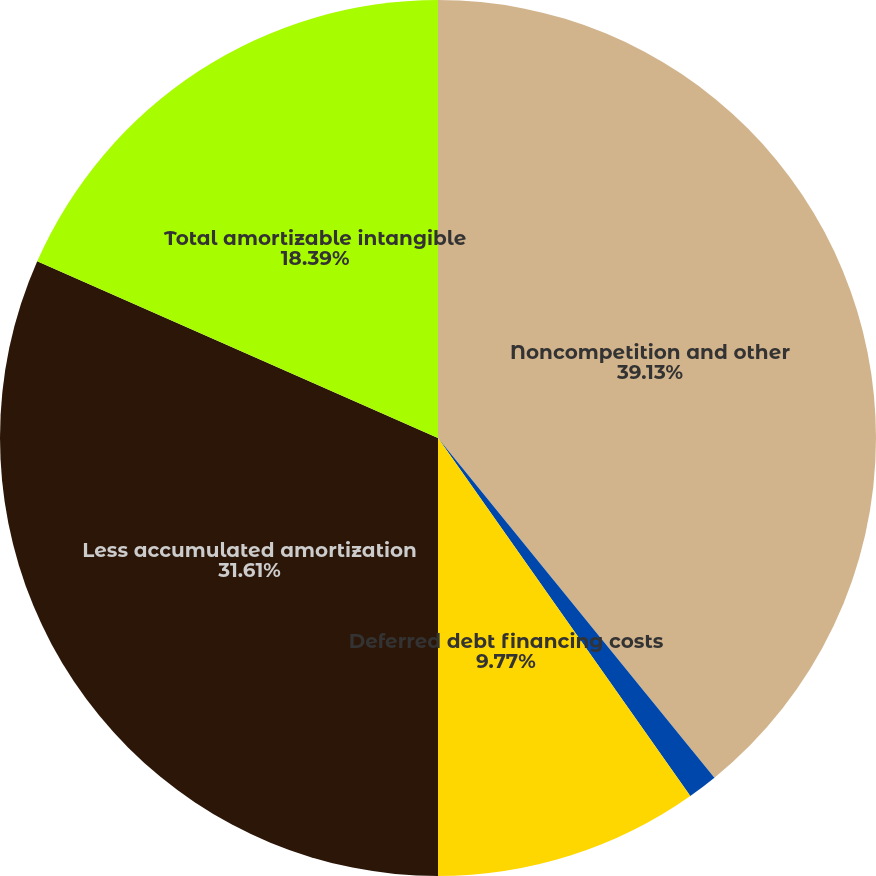Convert chart to OTSL. <chart><loc_0><loc_0><loc_500><loc_500><pie_chart><fcel>Noncompetition and other<fcel>Lease agreements<fcel>Deferred debt financing costs<fcel>Less accumulated amortization<fcel>Total amortizable intangible<nl><fcel>39.13%<fcel>1.1%<fcel>9.77%<fcel>31.61%<fcel>18.39%<nl></chart> 